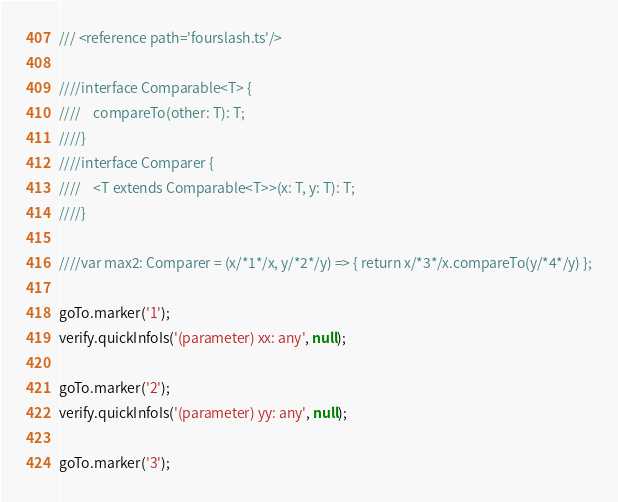Convert code to text. <code><loc_0><loc_0><loc_500><loc_500><_TypeScript_>/// <reference path='fourslash.ts'/>

////interface Comparable<T> {
////    compareTo(other: T): T;
////}
////interface Comparer {
////    <T extends Comparable<T>>(x: T, y: T): T;
////}

////var max2: Comparer = (x/*1*/x, y/*2*/y) => { return x/*3*/x.compareTo(y/*4*/y) };

goTo.marker('1');
verify.quickInfoIs('(parameter) xx: any', null);

goTo.marker('2');
verify.quickInfoIs('(parameter) yy: any', null);

goTo.marker('3');</code> 